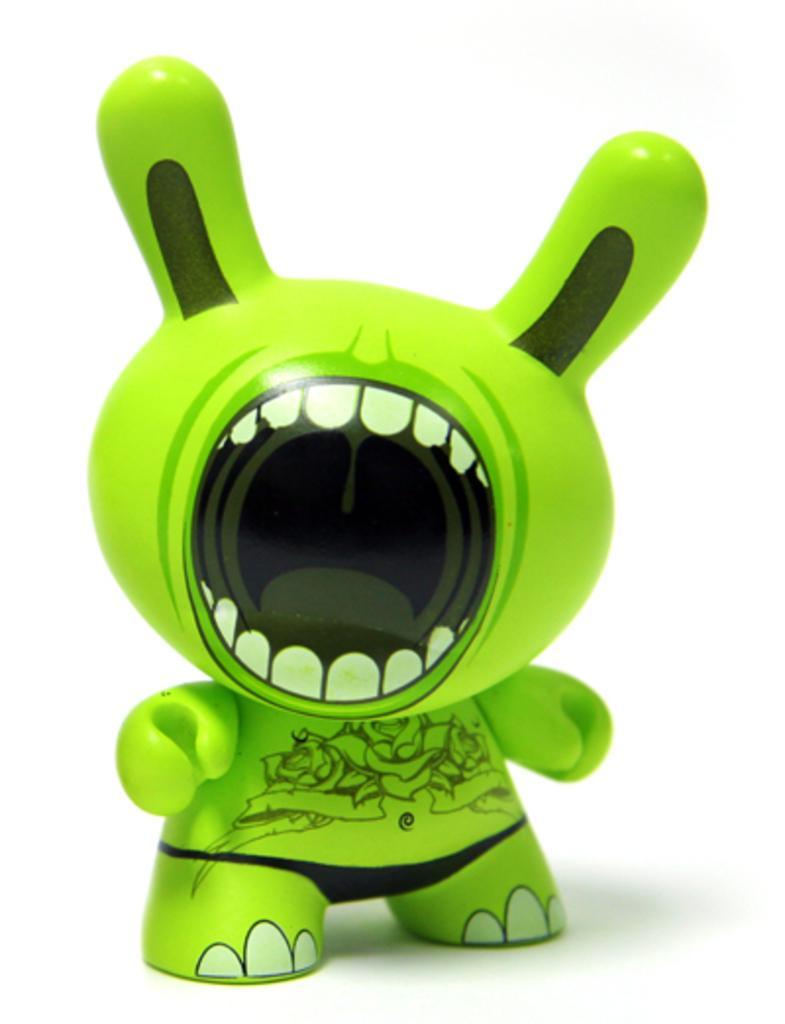Describe this image in one or two sentences. There is a green toy and there is a white background. 